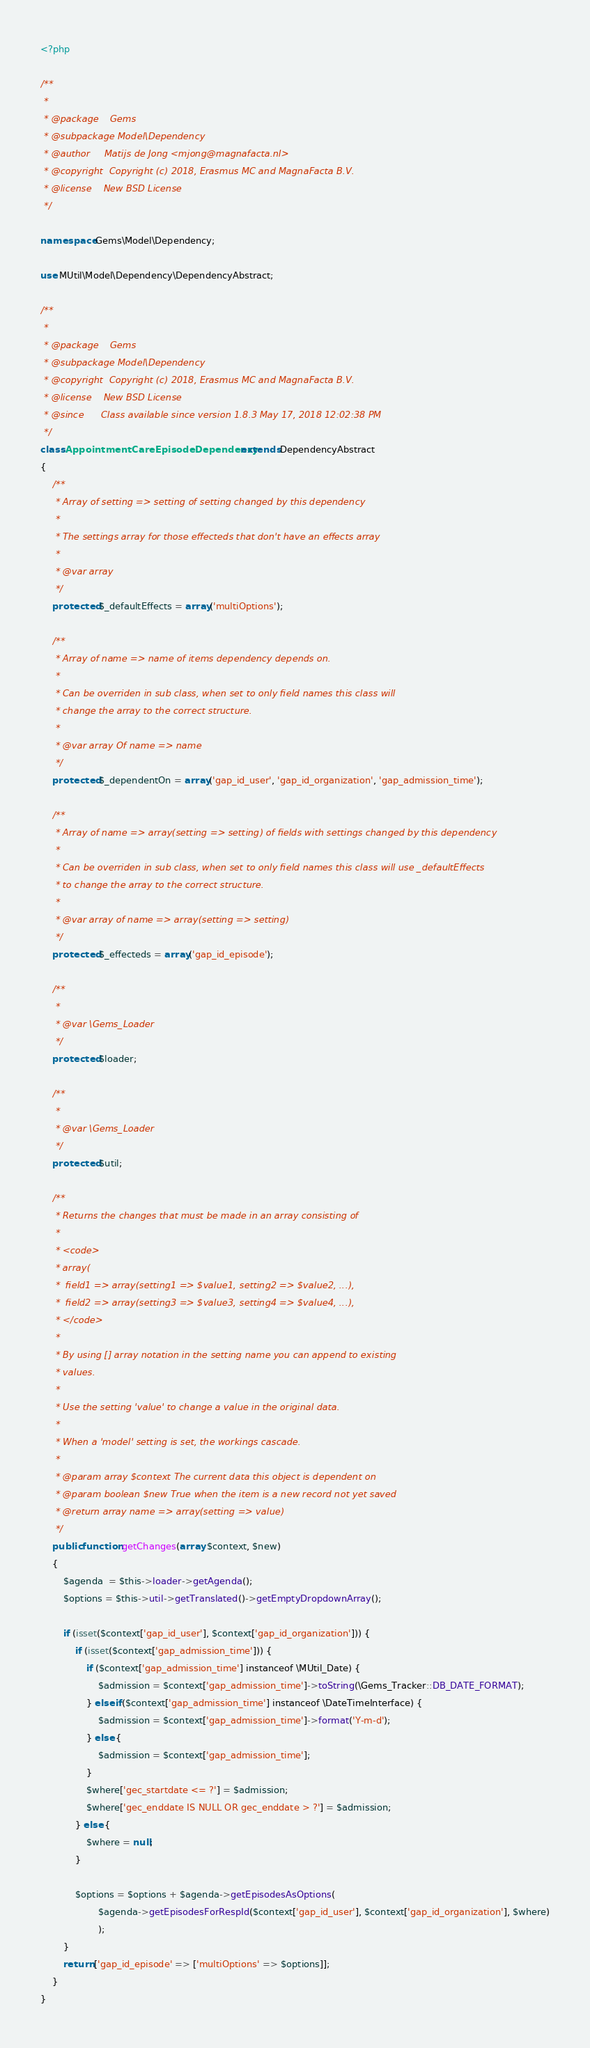<code> <loc_0><loc_0><loc_500><loc_500><_PHP_><?php

/**
 *
 * @package    Gems
 * @subpackage Model\Dependency
 * @author     Matijs de Jong <mjong@magnafacta.nl>
 * @copyright  Copyright (c) 2018, Erasmus MC and MagnaFacta B.V.
 * @license    New BSD License
 */

namespace Gems\Model\Dependency;

use MUtil\Model\Dependency\DependencyAbstract;

/**
 *
 * @package    Gems
 * @subpackage Model\Dependency
 * @copyright  Copyright (c) 2018, Erasmus MC and MagnaFacta B.V.
 * @license    New BSD License
 * @since      Class available since version 1.8.3 May 17, 2018 12:02:38 PM
 */
class AppointmentCareEpisodeDependency extends DependencyAbstract
{
    /**
     * Array of setting => setting of setting changed by this dependency
     *
     * The settings array for those effecteds that don't have an effects array
     *
     * @var array
     */
    protected $_defaultEffects = array('multiOptions');

    /**
     * Array of name => name of items dependency depends on.
     *
     * Can be overriden in sub class, when set to only field names this class will
     * change the array to the correct structure.
     *
     * @var array Of name => name
     */
    protected $_dependentOn = array('gap_id_user', 'gap_id_organization', 'gap_admission_time');

    /**
     * Array of name => array(setting => setting) of fields with settings changed by this dependency
     *
     * Can be overriden in sub class, when set to only field names this class will use _defaultEffects
     * to change the array to the correct structure.
     *
     * @var array of name => array(setting => setting)
     */
    protected $_effecteds = array('gap_id_episode');

    /**
     *
     * @var \Gems_Loader
     */
    protected $loader;

    /**
     *
     * @var \Gems_Loader
     */
    protected $util;

    /**
     * Returns the changes that must be made in an array consisting of
     *
     * <code>
     * array(
     *  field1 => array(setting1 => $value1, setting2 => $value2, ...),
     *  field2 => array(setting3 => $value3, setting4 => $value4, ...),
     * </code>
     *
     * By using [] array notation in the setting name you can append to existing
     * values.
     *
     * Use the setting 'value' to change a value in the original data.
     *
     * When a 'model' setting is set, the workings cascade.
     *
     * @param array $context The current data this object is dependent on
     * @param boolean $new True when the item is a new record not yet saved
     * @return array name => array(setting => value)
     */
    public function getChanges(array $context, $new)
    {
        $agenda  = $this->loader->getAgenda();
        $options = $this->util->getTranslated()->getEmptyDropdownArray();

        if (isset($context['gap_id_user'], $context['gap_id_organization'])) {
            if (isset($context['gap_admission_time'])) {
                if ($context['gap_admission_time'] instanceof \MUtil_Date) {
                    $admission = $context['gap_admission_time']->toString(\Gems_Tracker::DB_DATE_FORMAT);
                } elseif ($context['gap_admission_time'] instanceof \DateTimeInterface) {
                    $admission = $context['gap_admission_time']->format('Y-m-d');
                } else {
                    $admission = $context['gap_admission_time'];
                }
                $where['gec_startdate <= ?'] = $admission;
                $where['gec_enddate IS NULL OR gec_enddate > ?'] = $admission;
            } else {
                $where = null;
            }

            $options = $options + $agenda->getEpisodesAsOptions(
                    $agenda->getEpisodesForRespId($context['gap_id_user'], $context['gap_id_organization'], $where)
                    );
        }
        return ['gap_id_episode' => ['multiOptions' => $options]];
    }
}
</code> 